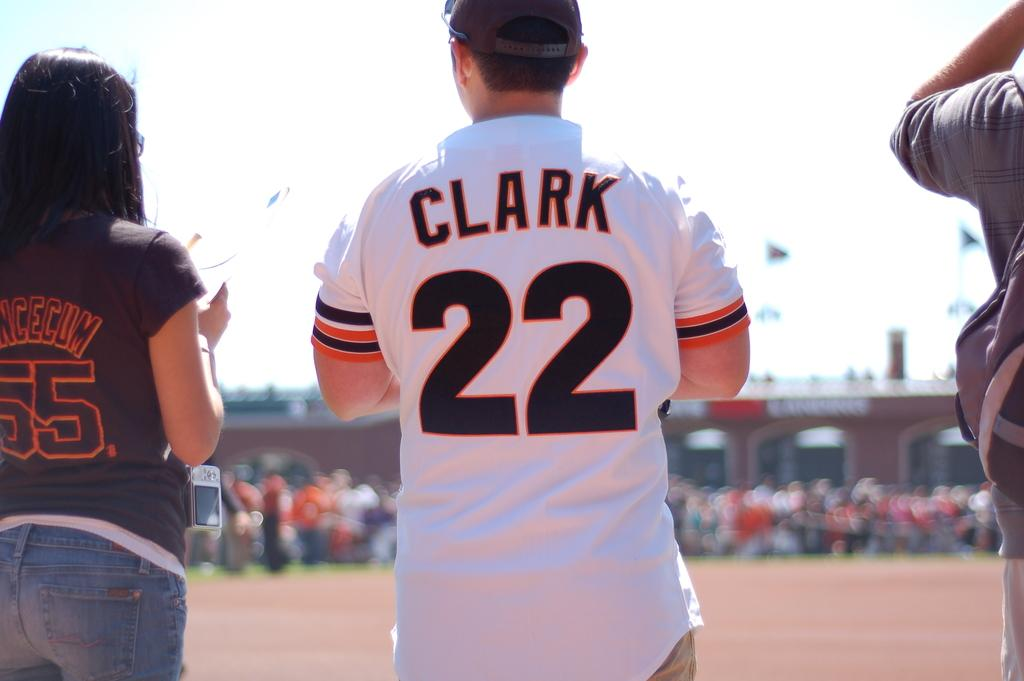<image>
Summarize the visual content of the image. A man stands with other people while wearing a jersey that reads Clark 22 on it. 